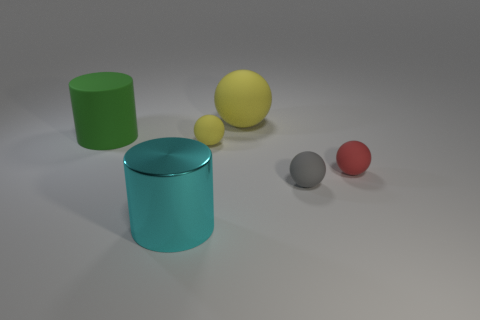Subtract all gray balls. How many balls are left? 3 Subtract all red blocks. How many yellow balls are left? 2 Subtract all yellow balls. How many balls are left? 2 Subtract 2 spheres. How many spheres are left? 2 Add 4 tiny metal blocks. How many objects exist? 10 Subtract all cylinders. How many objects are left? 4 Add 2 small matte things. How many small matte things are left? 5 Add 4 large cyan cylinders. How many large cyan cylinders exist? 5 Subtract 1 cyan cylinders. How many objects are left? 5 Subtract all cyan balls. Subtract all brown cylinders. How many balls are left? 4 